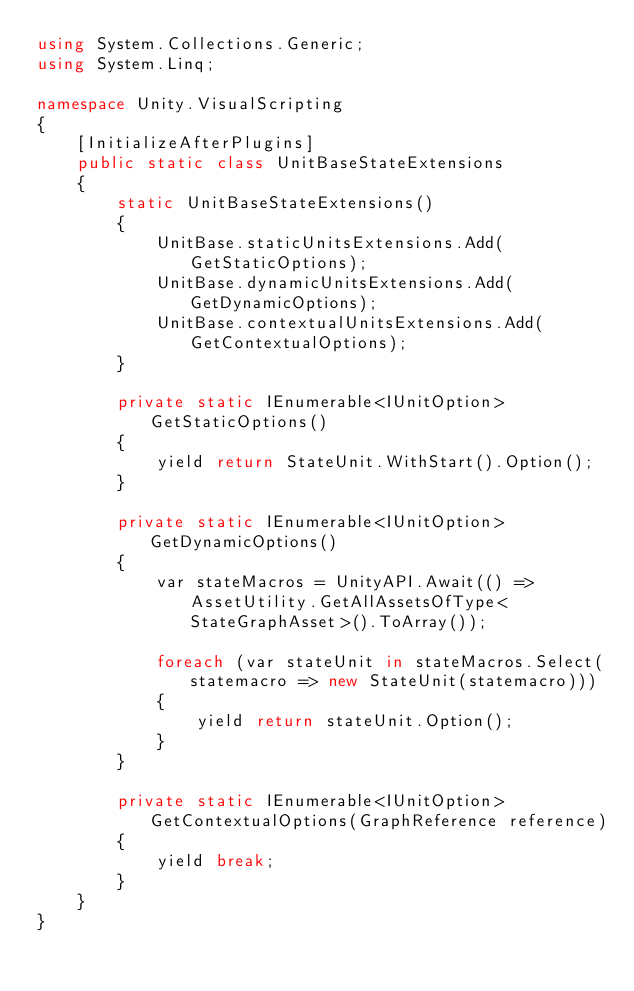Convert code to text. <code><loc_0><loc_0><loc_500><loc_500><_C#_>using System.Collections.Generic;
using System.Linq;

namespace Unity.VisualScripting
{
    [InitializeAfterPlugins]
    public static class UnitBaseStateExtensions
    {
        static UnitBaseStateExtensions()
        {
            UnitBase.staticUnitsExtensions.Add(GetStaticOptions);
            UnitBase.dynamicUnitsExtensions.Add(GetDynamicOptions);
            UnitBase.contextualUnitsExtensions.Add(GetContextualOptions);
        }

        private static IEnumerable<IUnitOption> GetStaticOptions()
        {
            yield return StateUnit.WithStart().Option();
        }

        private static IEnumerable<IUnitOption> GetDynamicOptions()
        {
            var stateMacros = UnityAPI.Await(() => AssetUtility.GetAllAssetsOfType<StateGraphAsset>().ToArray());

            foreach (var stateUnit in stateMacros.Select(statemacro => new StateUnit(statemacro)))
            {
                yield return stateUnit.Option();
            }
        }

        private static IEnumerable<IUnitOption> GetContextualOptions(GraphReference reference)
        {
            yield break;
        }
    }
}
</code> 